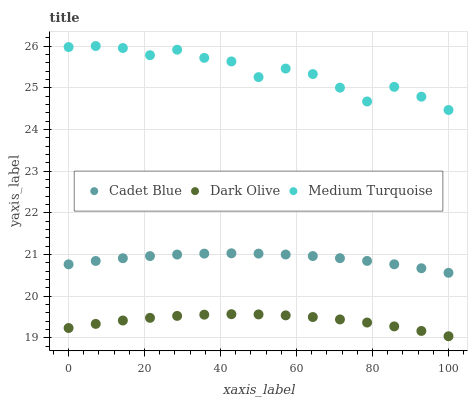Does Dark Olive have the minimum area under the curve?
Answer yes or no. Yes. Does Medium Turquoise have the maximum area under the curve?
Answer yes or no. Yes. Does Cadet Blue have the minimum area under the curve?
Answer yes or no. No. Does Cadet Blue have the maximum area under the curve?
Answer yes or no. No. Is Cadet Blue the smoothest?
Answer yes or no. Yes. Is Medium Turquoise the roughest?
Answer yes or no. Yes. Is Medium Turquoise the smoothest?
Answer yes or no. No. Is Cadet Blue the roughest?
Answer yes or no. No. Does Dark Olive have the lowest value?
Answer yes or no. Yes. Does Cadet Blue have the lowest value?
Answer yes or no. No. Does Medium Turquoise have the highest value?
Answer yes or no. Yes. Does Cadet Blue have the highest value?
Answer yes or no. No. Is Cadet Blue less than Medium Turquoise?
Answer yes or no. Yes. Is Medium Turquoise greater than Dark Olive?
Answer yes or no. Yes. Does Cadet Blue intersect Medium Turquoise?
Answer yes or no. No. 